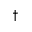<formula> <loc_0><loc_0><loc_500><loc_500>^ { \dagger }</formula> 